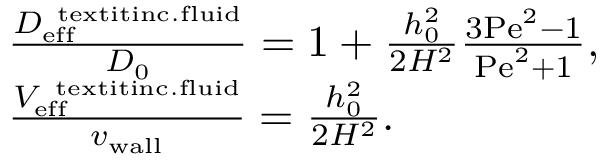Convert formula to latex. <formula><loc_0><loc_0><loc_500><loc_500>\begin{array} { r l } & { \frac { D _ { e f f } ^ { \ t e x t i t { i n c . f l u i d } } } { D _ { 0 } } = 1 + \frac { h _ { 0 } ^ { 2 } } { 2 H ^ { 2 } } \frac { 3 P e ^ { 2 } - 1 } { P e ^ { 2 } + 1 } , } \\ & { \frac { V _ { e f f } ^ { \ t e x t i t { i n c . f l u i d } } } { { v _ { w a l l } } } = \frac { h _ { 0 } ^ { 2 } } { 2 H ^ { 2 } } . } \end{array}</formula> 